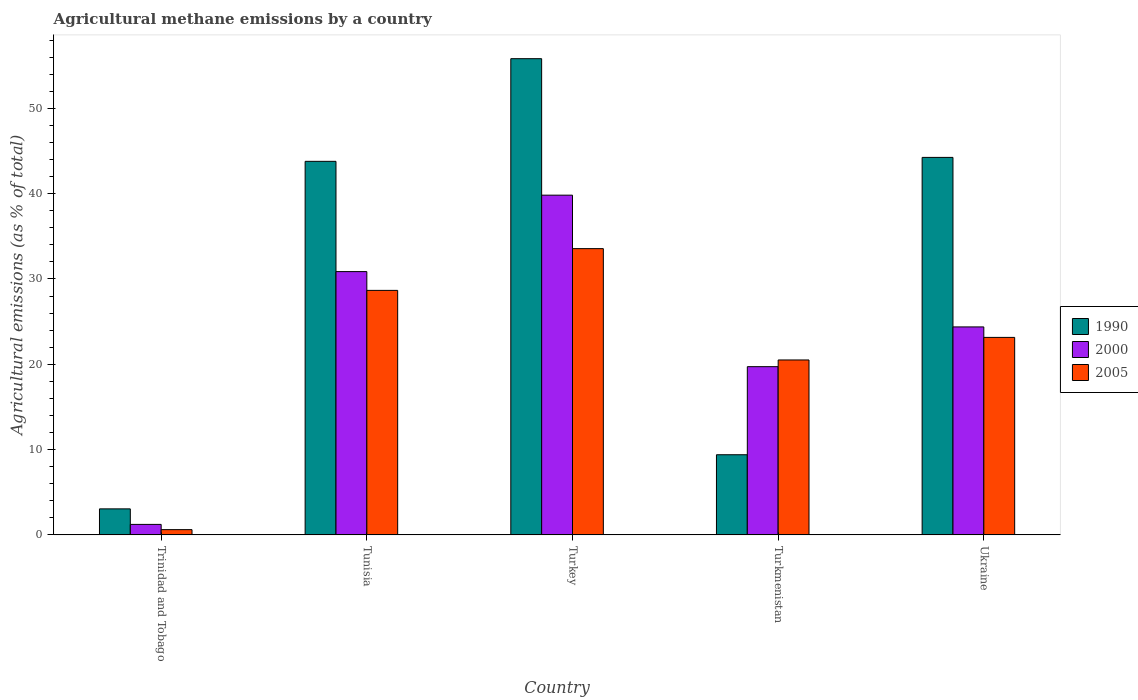How many groups of bars are there?
Ensure brevity in your answer.  5. Are the number of bars per tick equal to the number of legend labels?
Offer a very short reply. Yes. Are the number of bars on each tick of the X-axis equal?
Offer a very short reply. Yes. How many bars are there on the 4th tick from the left?
Provide a short and direct response. 3. What is the label of the 4th group of bars from the left?
Provide a succinct answer. Turkmenistan. What is the amount of agricultural methane emitted in 1990 in Tunisia?
Make the answer very short. 43.79. Across all countries, what is the maximum amount of agricultural methane emitted in 2005?
Your answer should be very brief. 33.56. Across all countries, what is the minimum amount of agricultural methane emitted in 2000?
Your answer should be very brief. 1.23. In which country was the amount of agricultural methane emitted in 2005 maximum?
Offer a terse response. Turkey. In which country was the amount of agricultural methane emitted in 1990 minimum?
Your answer should be very brief. Trinidad and Tobago. What is the total amount of agricultural methane emitted in 2000 in the graph?
Your answer should be very brief. 116.03. What is the difference between the amount of agricultural methane emitted in 1990 in Turkmenistan and that in Ukraine?
Your response must be concise. -34.86. What is the difference between the amount of agricultural methane emitted in 2000 in Turkmenistan and the amount of agricultural methane emitted in 1990 in Ukraine?
Make the answer very short. -24.53. What is the average amount of agricultural methane emitted in 2005 per country?
Keep it short and to the point. 21.3. What is the difference between the amount of agricultural methane emitted of/in 2000 and amount of agricultural methane emitted of/in 2005 in Turkmenistan?
Offer a terse response. -0.79. What is the ratio of the amount of agricultural methane emitted in 2005 in Tunisia to that in Ukraine?
Give a very brief answer. 1.24. What is the difference between the highest and the second highest amount of agricultural methane emitted in 1990?
Make the answer very short. -0.46. What is the difference between the highest and the lowest amount of agricultural methane emitted in 2000?
Provide a succinct answer. 38.6. Is the sum of the amount of agricultural methane emitted in 2000 in Tunisia and Ukraine greater than the maximum amount of agricultural methane emitted in 1990 across all countries?
Ensure brevity in your answer.  No. What does the 1st bar from the left in Ukraine represents?
Make the answer very short. 1990. How many bars are there?
Ensure brevity in your answer.  15. Are all the bars in the graph horizontal?
Your answer should be compact. No. How many countries are there in the graph?
Your response must be concise. 5. Are the values on the major ticks of Y-axis written in scientific E-notation?
Keep it short and to the point. No. Does the graph contain any zero values?
Make the answer very short. No. Does the graph contain grids?
Your response must be concise. No. How are the legend labels stacked?
Give a very brief answer. Vertical. What is the title of the graph?
Offer a terse response. Agricultural methane emissions by a country. What is the label or title of the Y-axis?
Offer a very short reply. Agricultural emissions (as % of total). What is the Agricultural emissions (as % of total) in 1990 in Trinidad and Tobago?
Provide a succinct answer. 3.05. What is the Agricultural emissions (as % of total) in 2000 in Trinidad and Tobago?
Give a very brief answer. 1.23. What is the Agricultural emissions (as % of total) in 2005 in Trinidad and Tobago?
Offer a very short reply. 0.62. What is the Agricultural emissions (as % of total) in 1990 in Tunisia?
Provide a short and direct response. 43.79. What is the Agricultural emissions (as % of total) in 2000 in Tunisia?
Give a very brief answer. 30.87. What is the Agricultural emissions (as % of total) of 2005 in Tunisia?
Provide a succinct answer. 28.66. What is the Agricultural emissions (as % of total) in 1990 in Turkey?
Ensure brevity in your answer.  55.83. What is the Agricultural emissions (as % of total) of 2000 in Turkey?
Keep it short and to the point. 39.83. What is the Agricultural emissions (as % of total) of 2005 in Turkey?
Offer a terse response. 33.56. What is the Agricultural emissions (as % of total) of 1990 in Turkmenistan?
Provide a short and direct response. 9.4. What is the Agricultural emissions (as % of total) of 2000 in Turkmenistan?
Offer a terse response. 19.72. What is the Agricultural emissions (as % of total) in 2005 in Turkmenistan?
Offer a terse response. 20.51. What is the Agricultural emissions (as % of total) of 1990 in Ukraine?
Make the answer very short. 44.25. What is the Agricultural emissions (as % of total) in 2000 in Ukraine?
Ensure brevity in your answer.  24.38. What is the Agricultural emissions (as % of total) in 2005 in Ukraine?
Provide a succinct answer. 23.15. Across all countries, what is the maximum Agricultural emissions (as % of total) of 1990?
Your answer should be very brief. 55.83. Across all countries, what is the maximum Agricultural emissions (as % of total) in 2000?
Your response must be concise. 39.83. Across all countries, what is the maximum Agricultural emissions (as % of total) in 2005?
Your response must be concise. 33.56. Across all countries, what is the minimum Agricultural emissions (as % of total) of 1990?
Offer a terse response. 3.05. Across all countries, what is the minimum Agricultural emissions (as % of total) of 2000?
Offer a very short reply. 1.23. Across all countries, what is the minimum Agricultural emissions (as % of total) of 2005?
Your answer should be compact. 0.62. What is the total Agricultural emissions (as % of total) of 1990 in the graph?
Keep it short and to the point. 156.32. What is the total Agricultural emissions (as % of total) of 2000 in the graph?
Your response must be concise. 116.03. What is the total Agricultural emissions (as % of total) of 2005 in the graph?
Ensure brevity in your answer.  106.5. What is the difference between the Agricultural emissions (as % of total) of 1990 in Trinidad and Tobago and that in Tunisia?
Your answer should be very brief. -40.74. What is the difference between the Agricultural emissions (as % of total) of 2000 in Trinidad and Tobago and that in Tunisia?
Provide a short and direct response. -29.64. What is the difference between the Agricultural emissions (as % of total) in 2005 in Trinidad and Tobago and that in Tunisia?
Offer a terse response. -28.05. What is the difference between the Agricultural emissions (as % of total) of 1990 in Trinidad and Tobago and that in Turkey?
Make the answer very short. -52.78. What is the difference between the Agricultural emissions (as % of total) in 2000 in Trinidad and Tobago and that in Turkey?
Your answer should be compact. -38.6. What is the difference between the Agricultural emissions (as % of total) of 2005 in Trinidad and Tobago and that in Turkey?
Provide a succinct answer. -32.94. What is the difference between the Agricultural emissions (as % of total) in 1990 in Trinidad and Tobago and that in Turkmenistan?
Your answer should be compact. -6.35. What is the difference between the Agricultural emissions (as % of total) in 2000 in Trinidad and Tobago and that in Turkmenistan?
Your response must be concise. -18.49. What is the difference between the Agricultural emissions (as % of total) of 2005 in Trinidad and Tobago and that in Turkmenistan?
Your response must be concise. -19.89. What is the difference between the Agricultural emissions (as % of total) in 1990 in Trinidad and Tobago and that in Ukraine?
Keep it short and to the point. -41.2. What is the difference between the Agricultural emissions (as % of total) in 2000 in Trinidad and Tobago and that in Ukraine?
Ensure brevity in your answer.  -23.15. What is the difference between the Agricultural emissions (as % of total) in 2005 in Trinidad and Tobago and that in Ukraine?
Offer a very short reply. -22.54. What is the difference between the Agricultural emissions (as % of total) in 1990 in Tunisia and that in Turkey?
Your answer should be compact. -12.03. What is the difference between the Agricultural emissions (as % of total) in 2000 in Tunisia and that in Turkey?
Give a very brief answer. -8.96. What is the difference between the Agricultural emissions (as % of total) in 2005 in Tunisia and that in Turkey?
Make the answer very short. -4.9. What is the difference between the Agricultural emissions (as % of total) in 1990 in Tunisia and that in Turkmenistan?
Provide a succinct answer. 34.4. What is the difference between the Agricultural emissions (as % of total) in 2000 in Tunisia and that in Turkmenistan?
Offer a terse response. 11.14. What is the difference between the Agricultural emissions (as % of total) in 2005 in Tunisia and that in Turkmenistan?
Give a very brief answer. 8.16. What is the difference between the Agricultural emissions (as % of total) of 1990 in Tunisia and that in Ukraine?
Your answer should be very brief. -0.46. What is the difference between the Agricultural emissions (as % of total) of 2000 in Tunisia and that in Ukraine?
Keep it short and to the point. 6.49. What is the difference between the Agricultural emissions (as % of total) in 2005 in Tunisia and that in Ukraine?
Your response must be concise. 5.51. What is the difference between the Agricultural emissions (as % of total) in 1990 in Turkey and that in Turkmenistan?
Offer a very short reply. 46.43. What is the difference between the Agricultural emissions (as % of total) of 2000 in Turkey and that in Turkmenistan?
Offer a very short reply. 20.11. What is the difference between the Agricultural emissions (as % of total) in 2005 in Turkey and that in Turkmenistan?
Keep it short and to the point. 13.05. What is the difference between the Agricultural emissions (as % of total) of 1990 in Turkey and that in Ukraine?
Provide a succinct answer. 11.57. What is the difference between the Agricultural emissions (as % of total) in 2000 in Turkey and that in Ukraine?
Keep it short and to the point. 15.45. What is the difference between the Agricultural emissions (as % of total) in 2005 in Turkey and that in Ukraine?
Give a very brief answer. 10.41. What is the difference between the Agricultural emissions (as % of total) in 1990 in Turkmenistan and that in Ukraine?
Provide a short and direct response. -34.86. What is the difference between the Agricultural emissions (as % of total) of 2000 in Turkmenistan and that in Ukraine?
Ensure brevity in your answer.  -4.66. What is the difference between the Agricultural emissions (as % of total) of 2005 in Turkmenistan and that in Ukraine?
Provide a succinct answer. -2.65. What is the difference between the Agricultural emissions (as % of total) in 1990 in Trinidad and Tobago and the Agricultural emissions (as % of total) in 2000 in Tunisia?
Give a very brief answer. -27.81. What is the difference between the Agricultural emissions (as % of total) in 1990 in Trinidad and Tobago and the Agricultural emissions (as % of total) in 2005 in Tunisia?
Your response must be concise. -25.61. What is the difference between the Agricultural emissions (as % of total) of 2000 in Trinidad and Tobago and the Agricultural emissions (as % of total) of 2005 in Tunisia?
Your answer should be very brief. -27.43. What is the difference between the Agricultural emissions (as % of total) in 1990 in Trinidad and Tobago and the Agricultural emissions (as % of total) in 2000 in Turkey?
Make the answer very short. -36.78. What is the difference between the Agricultural emissions (as % of total) of 1990 in Trinidad and Tobago and the Agricultural emissions (as % of total) of 2005 in Turkey?
Your answer should be compact. -30.51. What is the difference between the Agricultural emissions (as % of total) in 2000 in Trinidad and Tobago and the Agricultural emissions (as % of total) in 2005 in Turkey?
Give a very brief answer. -32.33. What is the difference between the Agricultural emissions (as % of total) of 1990 in Trinidad and Tobago and the Agricultural emissions (as % of total) of 2000 in Turkmenistan?
Keep it short and to the point. -16.67. What is the difference between the Agricultural emissions (as % of total) of 1990 in Trinidad and Tobago and the Agricultural emissions (as % of total) of 2005 in Turkmenistan?
Your response must be concise. -17.46. What is the difference between the Agricultural emissions (as % of total) in 2000 in Trinidad and Tobago and the Agricultural emissions (as % of total) in 2005 in Turkmenistan?
Offer a terse response. -19.28. What is the difference between the Agricultural emissions (as % of total) of 1990 in Trinidad and Tobago and the Agricultural emissions (as % of total) of 2000 in Ukraine?
Make the answer very short. -21.33. What is the difference between the Agricultural emissions (as % of total) in 1990 in Trinidad and Tobago and the Agricultural emissions (as % of total) in 2005 in Ukraine?
Ensure brevity in your answer.  -20.1. What is the difference between the Agricultural emissions (as % of total) in 2000 in Trinidad and Tobago and the Agricultural emissions (as % of total) in 2005 in Ukraine?
Provide a succinct answer. -21.92. What is the difference between the Agricultural emissions (as % of total) of 1990 in Tunisia and the Agricultural emissions (as % of total) of 2000 in Turkey?
Your answer should be compact. 3.97. What is the difference between the Agricultural emissions (as % of total) of 1990 in Tunisia and the Agricultural emissions (as % of total) of 2005 in Turkey?
Give a very brief answer. 10.23. What is the difference between the Agricultural emissions (as % of total) of 2000 in Tunisia and the Agricultural emissions (as % of total) of 2005 in Turkey?
Ensure brevity in your answer.  -2.69. What is the difference between the Agricultural emissions (as % of total) in 1990 in Tunisia and the Agricultural emissions (as % of total) in 2000 in Turkmenistan?
Ensure brevity in your answer.  24.07. What is the difference between the Agricultural emissions (as % of total) in 1990 in Tunisia and the Agricultural emissions (as % of total) in 2005 in Turkmenistan?
Ensure brevity in your answer.  23.29. What is the difference between the Agricultural emissions (as % of total) of 2000 in Tunisia and the Agricultural emissions (as % of total) of 2005 in Turkmenistan?
Provide a short and direct response. 10.36. What is the difference between the Agricultural emissions (as % of total) in 1990 in Tunisia and the Agricultural emissions (as % of total) in 2000 in Ukraine?
Offer a terse response. 19.41. What is the difference between the Agricultural emissions (as % of total) of 1990 in Tunisia and the Agricultural emissions (as % of total) of 2005 in Ukraine?
Give a very brief answer. 20.64. What is the difference between the Agricultural emissions (as % of total) of 2000 in Tunisia and the Agricultural emissions (as % of total) of 2005 in Ukraine?
Your response must be concise. 7.71. What is the difference between the Agricultural emissions (as % of total) in 1990 in Turkey and the Agricultural emissions (as % of total) in 2000 in Turkmenistan?
Your answer should be very brief. 36.11. What is the difference between the Agricultural emissions (as % of total) in 1990 in Turkey and the Agricultural emissions (as % of total) in 2005 in Turkmenistan?
Offer a very short reply. 35.32. What is the difference between the Agricultural emissions (as % of total) of 2000 in Turkey and the Agricultural emissions (as % of total) of 2005 in Turkmenistan?
Offer a very short reply. 19.32. What is the difference between the Agricultural emissions (as % of total) in 1990 in Turkey and the Agricultural emissions (as % of total) in 2000 in Ukraine?
Your answer should be compact. 31.45. What is the difference between the Agricultural emissions (as % of total) of 1990 in Turkey and the Agricultural emissions (as % of total) of 2005 in Ukraine?
Your response must be concise. 32.67. What is the difference between the Agricultural emissions (as % of total) of 2000 in Turkey and the Agricultural emissions (as % of total) of 2005 in Ukraine?
Your answer should be compact. 16.67. What is the difference between the Agricultural emissions (as % of total) of 1990 in Turkmenistan and the Agricultural emissions (as % of total) of 2000 in Ukraine?
Your response must be concise. -14.98. What is the difference between the Agricultural emissions (as % of total) in 1990 in Turkmenistan and the Agricultural emissions (as % of total) in 2005 in Ukraine?
Keep it short and to the point. -13.76. What is the difference between the Agricultural emissions (as % of total) of 2000 in Turkmenistan and the Agricultural emissions (as % of total) of 2005 in Ukraine?
Offer a terse response. -3.43. What is the average Agricultural emissions (as % of total) of 1990 per country?
Provide a succinct answer. 31.26. What is the average Agricultural emissions (as % of total) of 2000 per country?
Provide a short and direct response. 23.21. What is the average Agricultural emissions (as % of total) of 2005 per country?
Keep it short and to the point. 21.3. What is the difference between the Agricultural emissions (as % of total) of 1990 and Agricultural emissions (as % of total) of 2000 in Trinidad and Tobago?
Offer a terse response. 1.82. What is the difference between the Agricultural emissions (as % of total) of 1990 and Agricultural emissions (as % of total) of 2005 in Trinidad and Tobago?
Ensure brevity in your answer.  2.44. What is the difference between the Agricultural emissions (as % of total) of 2000 and Agricultural emissions (as % of total) of 2005 in Trinidad and Tobago?
Ensure brevity in your answer.  0.61. What is the difference between the Agricultural emissions (as % of total) in 1990 and Agricultural emissions (as % of total) in 2000 in Tunisia?
Your response must be concise. 12.93. What is the difference between the Agricultural emissions (as % of total) in 1990 and Agricultural emissions (as % of total) in 2005 in Tunisia?
Offer a terse response. 15.13. What is the difference between the Agricultural emissions (as % of total) of 2000 and Agricultural emissions (as % of total) of 2005 in Tunisia?
Keep it short and to the point. 2.2. What is the difference between the Agricultural emissions (as % of total) in 1990 and Agricultural emissions (as % of total) in 2000 in Turkey?
Offer a terse response. 16. What is the difference between the Agricultural emissions (as % of total) in 1990 and Agricultural emissions (as % of total) in 2005 in Turkey?
Ensure brevity in your answer.  22.27. What is the difference between the Agricultural emissions (as % of total) in 2000 and Agricultural emissions (as % of total) in 2005 in Turkey?
Your answer should be very brief. 6.27. What is the difference between the Agricultural emissions (as % of total) in 1990 and Agricultural emissions (as % of total) in 2000 in Turkmenistan?
Keep it short and to the point. -10.32. What is the difference between the Agricultural emissions (as % of total) in 1990 and Agricultural emissions (as % of total) in 2005 in Turkmenistan?
Your response must be concise. -11.11. What is the difference between the Agricultural emissions (as % of total) in 2000 and Agricultural emissions (as % of total) in 2005 in Turkmenistan?
Provide a short and direct response. -0.79. What is the difference between the Agricultural emissions (as % of total) in 1990 and Agricultural emissions (as % of total) in 2000 in Ukraine?
Give a very brief answer. 19.87. What is the difference between the Agricultural emissions (as % of total) of 1990 and Agricultural emissions (as % of total) of 2005 in Ukraine?
Your response must be concise. 21.1. What is the difference between the Agricultural emissions (as % of total) in 2000 and Agricultural emissions (as % of total) in 2005 in Ukraine?
Your answer should be very brief. 1.23. What is the ratio of the Agricultural emissions (as % of total) of 1990 in Trinidad and Tobago to that in Tunisia?
Your response must be concise. 0.07. What is the ratio of the Agricultural emissions (as % of total) of 2000 in Trinidad and Tobago to that in Tunisia?
Make the answer very short. 0.04. What is the ratio of the Agricultural emissions (as % of total) in 2005 in Trinidad and Tobago to that in Tunisia?
Your answer should be very brief. 0.02. What is the ratio of the Agricultural emissions (as % of total) in 1990 in Trinidad and Tobago to that in Turkey?
Provide a short and direct response. 0.05. What is the ratio of the Agricultural emissions (as % of total) in 2000 in Trinidad and Tobago to that in Turkey?
Your answer should be very brief. 0.03. What is the ratio of the Agricultural emissions (as % of total) of 2005 in Trinidad and Tobago to that in Turkey?
Your answer should be compact. 0.02. What is the ratio of the Agricultural emissions (as % of total) of 1990 in Trinidad and Tobago to that in Turkmenistan?
Offer a very short reply. 0.32. What is the ratio of the Agricultural emissions (as % of total) of 2000 in Trinidad and Tobago to that in Turkmenistan?
Give a very brief answer. 0.06. What is the ratio of the Agricultural emissions (as % of total) in 2005 in Trinidad and Tobago to that in Turkmenistan?
Provide a succinct answer. 0.03. What is the ratio of the Agricultural emissions (as % of total) of 1990 in Trinidad and Tobago to that in Ukraine?
Provide a short and direct response. 0.07. What is the ratio of the Agricultural emissions (as % of total) of 2000 in Trinidad and Tobago to that in Ukraine?
Keep it short and to the point. 0.05. What is the ratio of the Agricultural emissions (as % of total) in 2005 in Trinidad and Tobago to that in Ukraine?
Make the answer very short. 0.03. What is the ratio of the Agricultural emissions (as % of total) in 1990 in Tunisia to that in Turkey?
Offer a very short reply. 0.78. What is the ratio of the Agricultural emissions (as % of total) in 2000 in Tunisia to that in Turkey?
Offer a terse response. 0.78. What is the ratio of the Agricultural emissions (as % of total) in 2005 in Tunisia to that in Turkey?
Your answer should be compact. 0.85. What is the ratio of the Agricultural emissions (as % of total) in 1990 in Tunisia to that in Turkmenistan?
Ensure brevity in your answer.  4.66. What is the ratio of the Agricultural emissions (as % of total) in 2000 in Tunisia to that in Turkmenistan?
Offer a terse response. 1.57. What is the ratio of the Agricultural emissions (as % of total) in 2005 in Tunisia to that in Turkmenistan?
Keep it short and to the point. 1.4. What is the ratio of the Agricultural emissions (as % of total) in 2000 in Tunisia to that in Ukraine?
Offer a very short reply. 1.27. What is the ratio of the Agricultural emissions (as % of total) in 2005 in Tunisia to that in Ukraine?
Provide a succinct answer. 1.24. What is the ratio of the Agricultural emissions (as % of total) in 1990 in Turkey to that in Turkmenistan?
Keep it short and to the point. 5.94. What is the ratio of the Agricultural emissions (as % of total) of 2000 in Turkey to that in Turkmenistan?
Offer a terse response. 2.02. What is the ratio of the Agricultural emissions (as % of total) in 2005 in Turkey to that in Turkmenistan?
Offer a very short reply. 1.64. What is the ratio of the Agricultural emissions (as % of total) of 1990 in Turkey to that in Ukraine?
Ensure brevity in your answer.  1.26. What is the ratio of the Agricultural emissions (as % of total) of 2000 in Turkey to that in Ukraine?
Make the answer very short. 1.63. What is the ratio of the Agricultural emissions (as % of total) in 2005 in Turkey to that in Ukraine?
Keep it short and to the point. 1.45. What is the ratio of the Agricultural emissions (as % of total) in 1990 in Turkmenistan to that in Ukraine?
Your answer should be compact. 0.21. What is the ratio of the Agricultural emissions (as % of total) in 2000 in Turkmenistan to that in Ukraine?
Keep it short and to the point. 0.81. What is the ratio of the Agricultural emissions (as % of total) of 2005 in Turkmenistan to that in Ukraine?
Make the answer very short. 0.89. What is the difference between the highest and the second highest Agricultural emissions (as % of total) in 1990?
Your answer should be compact. 11.57. What is the difference between the highest and the second highest Agricultural emissions (as % of total) of 2000?
Keep it short and to the point. 8.96. What is the difference between the highest and the second highest Agricultural emissions (as % of total) of 2005?
Make the answer very short. 4.9. What is the difference between the highest and the lowest Agricultural emissions (as % of total) of 1990?
Your answer should be compact. 52.78. What is the difference between the highest and the lowest Agricultural emissions (as % of total) of 2000?
Offer a terse response. 38.6. What is the difference between the highest and the lowest Agricultural emissions (as % of total) of 2005?
Give a very brief answer. 32.94. 